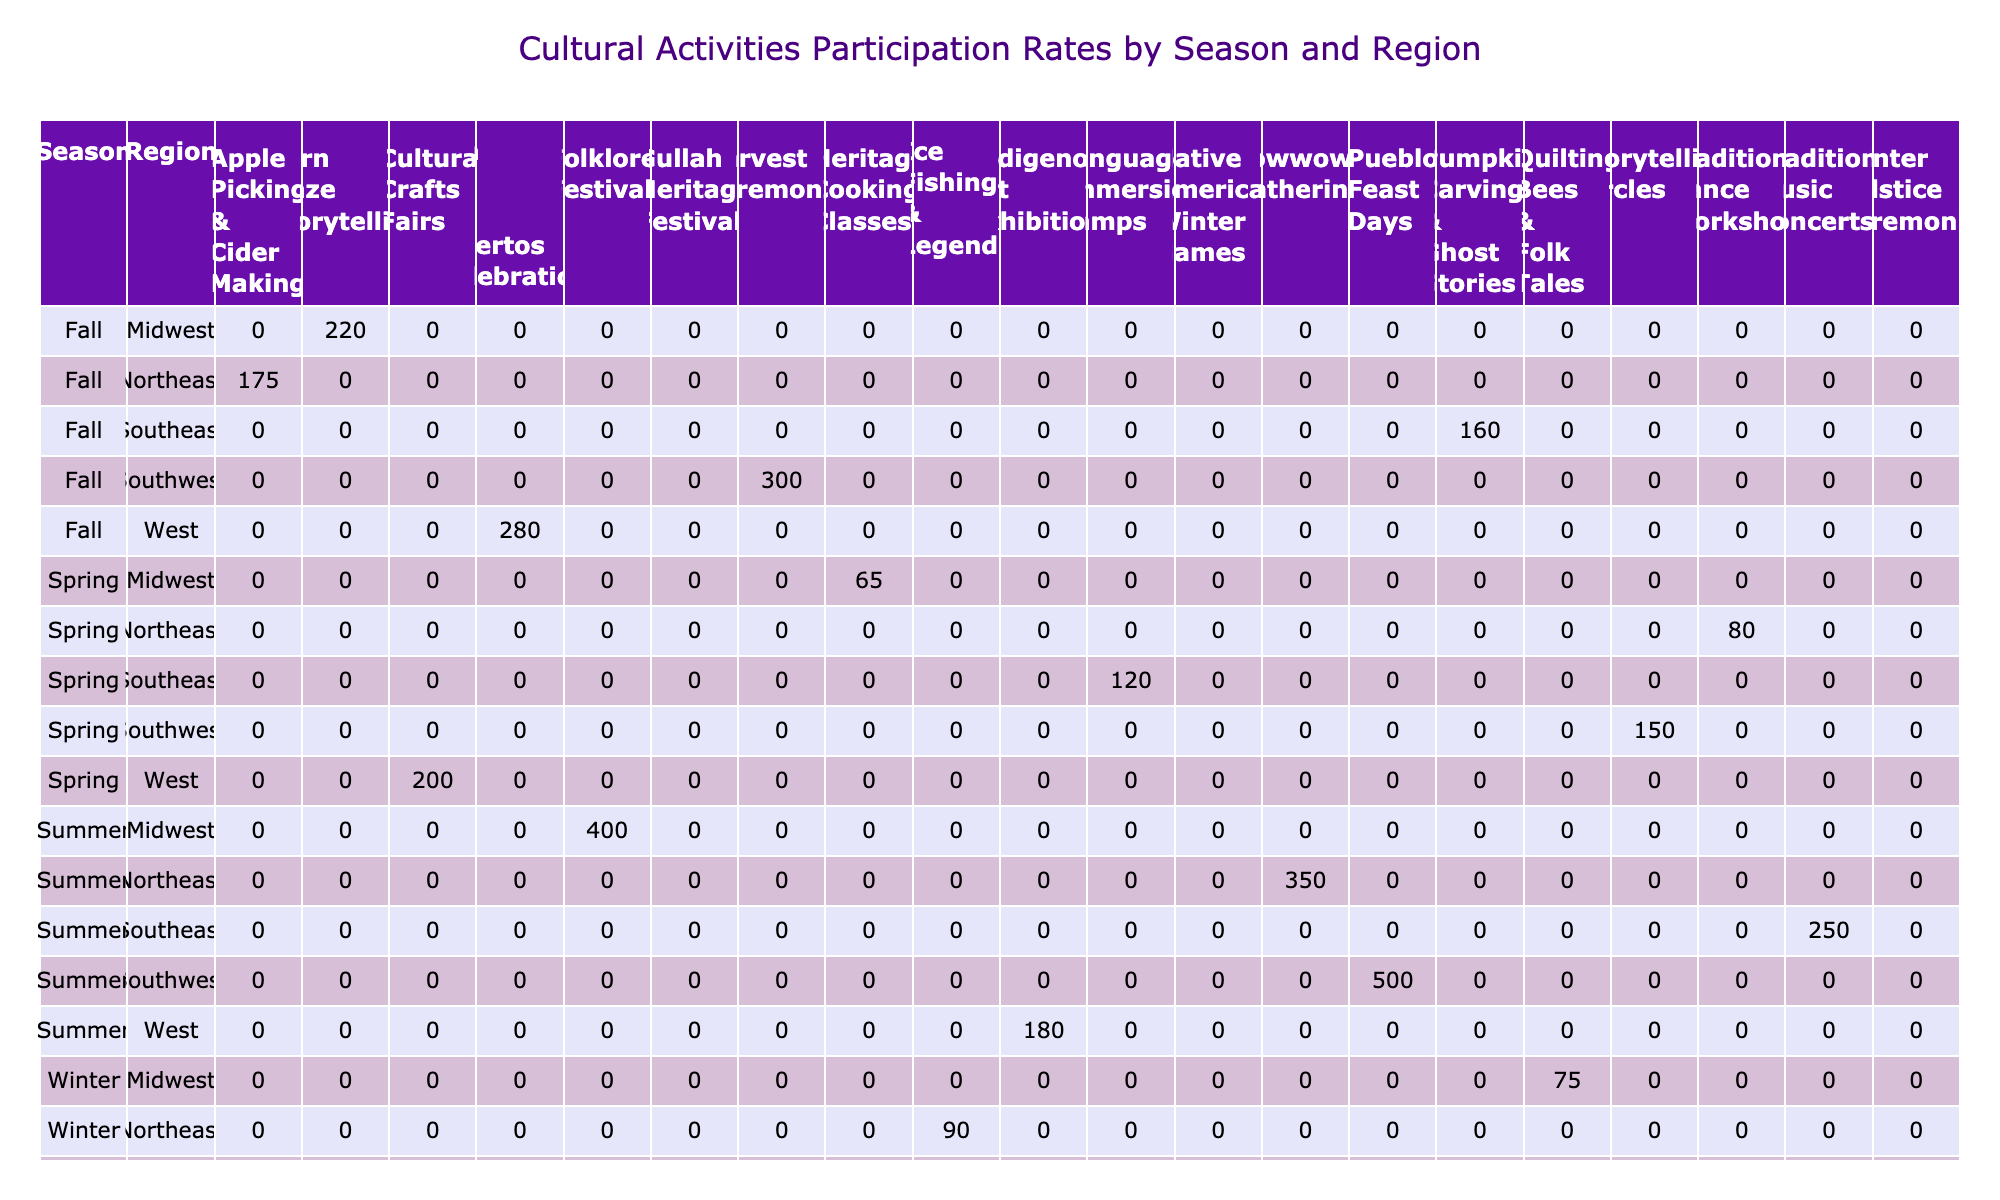What is the highest number of participants in a cultural activity during the summer season? The highest number of participants in a cultural activity during the summer is shown in the 'Southwest' region with 'Pueblo Feast Days' having 500 participants.
Answer: 500 Which region had the least participation in 'Traditional Dance Workshops'? The 'Northeast' region had the least participation in 'Traditional Dance Workshops' with 80 participants.
Answer: 80 What is the total number of participants in cultural activities for the 'Fall' season across all regions? Summing the participants for fall activities: 300 (Southwest) + 175 (Northeast) + 220 (Midwest) + 160 (Southeast) + 280 (West) gives a total of 1135 participants.
Answer: 1135 Did the 'Southeast' region have more participants in 'Language Immersion Camps' than the 'Northeast' region had in 'Powwow Gatherings'? The 'Southeast' region had 120 participants in 'Language Immersion Camps' while the 'Northeast' region had 350 participants in 'Powwow Gatherings', so the statement is false.
Answer: No Which activity in the 'West' region had the highest participation in the 'Winter' season? The activity with the highest participation in the 'West' region during the 'Winter' season was 'Native American Winter Games' with 110 participants.
Answer: 110 What is the average number of participants across all activities for the 'Spring' season? To find the average, calculate the total participants in spring: 150 + 80 + 65 + 120 + 200 = 615. Then, divide by the number of activities (5), which gives 615/5 = 123.
Answer: 123 In which season and region was storytelling featured as a cultural activity with the most participants? Storytelling was featured in the 'Fall' season in the 'Midwest' region with 'Corn Maze Storytelling' having 220 participants, which is the most among storytelling activities.
Answer: Fall, Midwest How many activities had a participation of over 200 in the 'Summer' season? The activities with over 200 participants in summer are: 'Pueblo Feast Days' (500), 'Powwow Gatherings' (350), 'Folklore Festivals' (400), and 'Traditional Music Concerts' (250), totaling 4 activities.
Answer: 4 